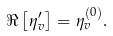Convert formula to latex. <formula><loc_0><loc_0><loc_500><loc_500>\Re \left [ \eta ^ { \prime } _ { v } \right ] = \eta ^ { \left ( 0 \right ) } _ { v } .</formula> 